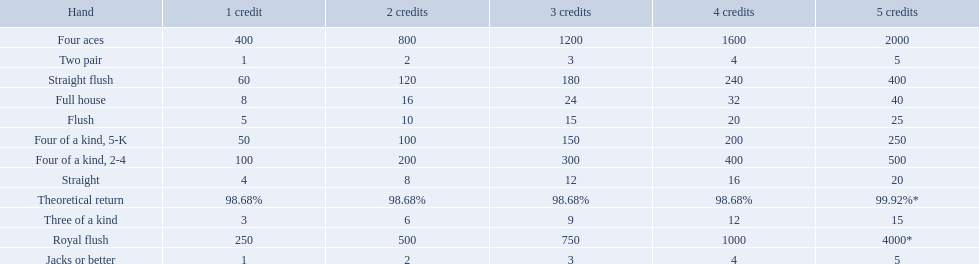What are the top 5 best types of hand for winning? Royal flush, Straight flush, Four aces, Four of a kind, 2-4, Four of a kind, 5-K. Between those 5, which of those hands are four of a kind? Four of a kind, 2-4, Four of a kind, 5-K. Of those 2 hands, which is the best kind of four of a kind for winning? Four of a kind, 2-4. 